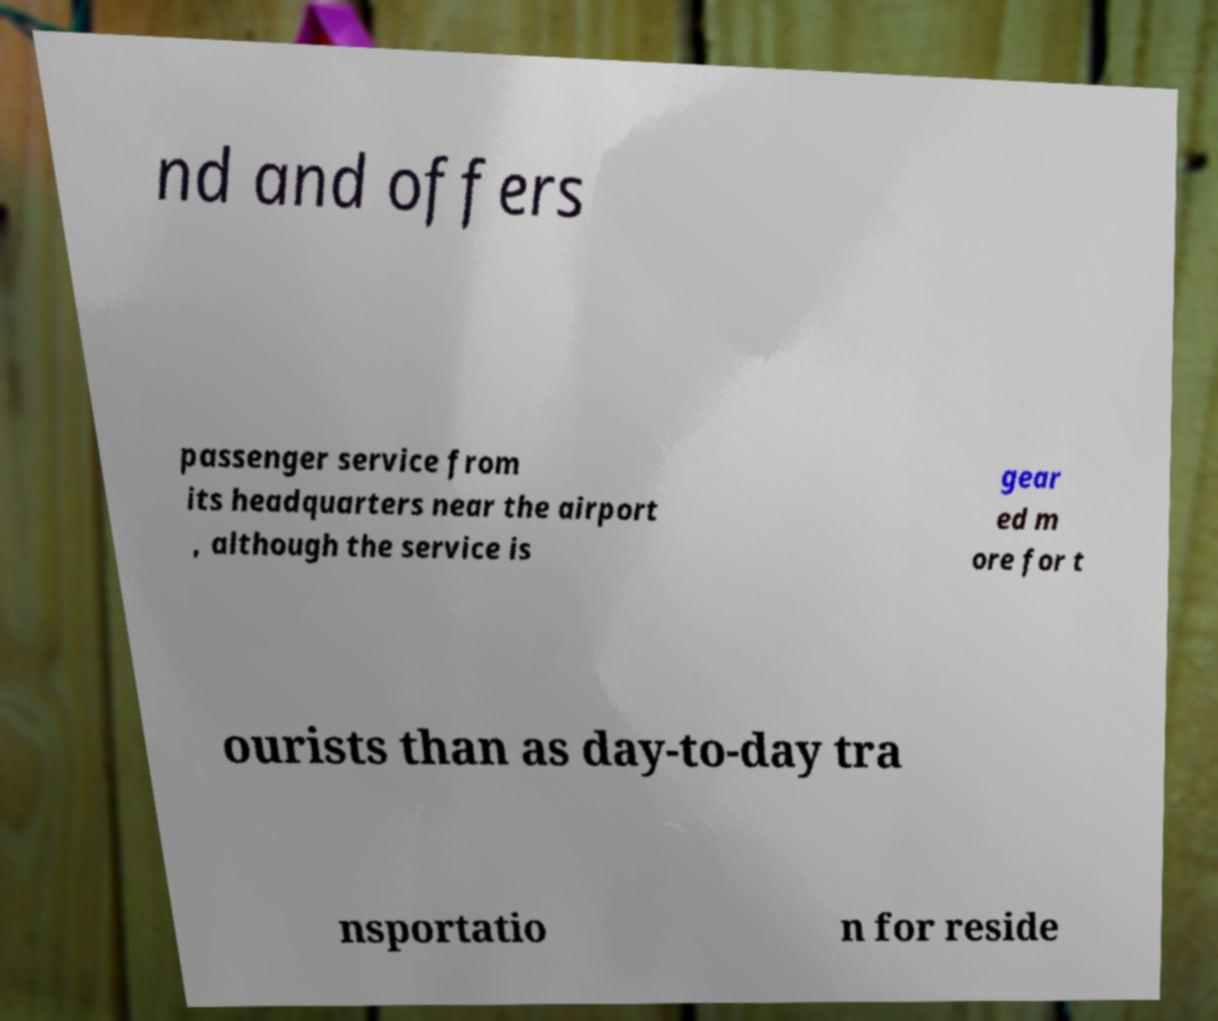Can you accurately transcribe the text from the provided image for me? nd and offers passenger service from its headquarters near the airport , although the service is gear ed m ore for t ourists than as day-to-day tra nsportatio n for reside 